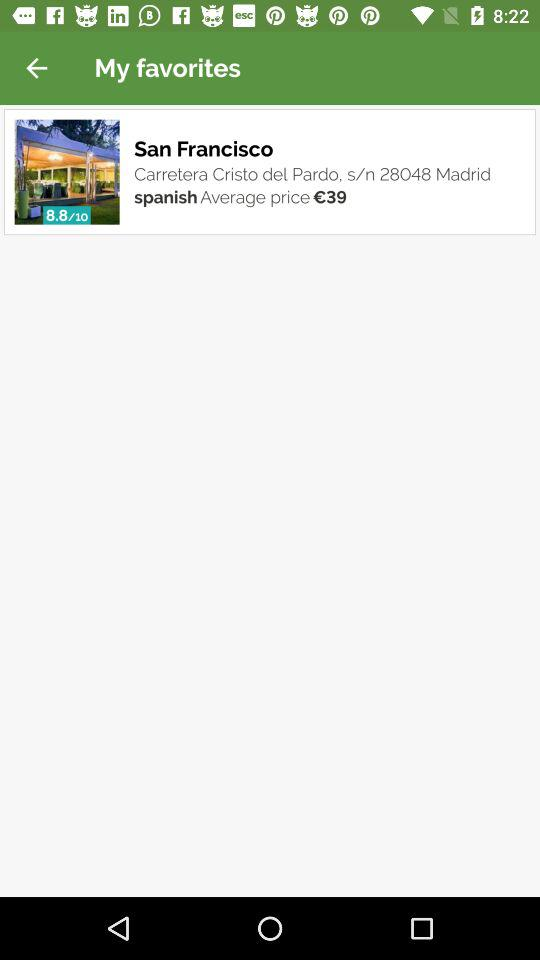How many euros is the average price of a meal at this restaurant?
Answer the question using a single word or phrase. 39 